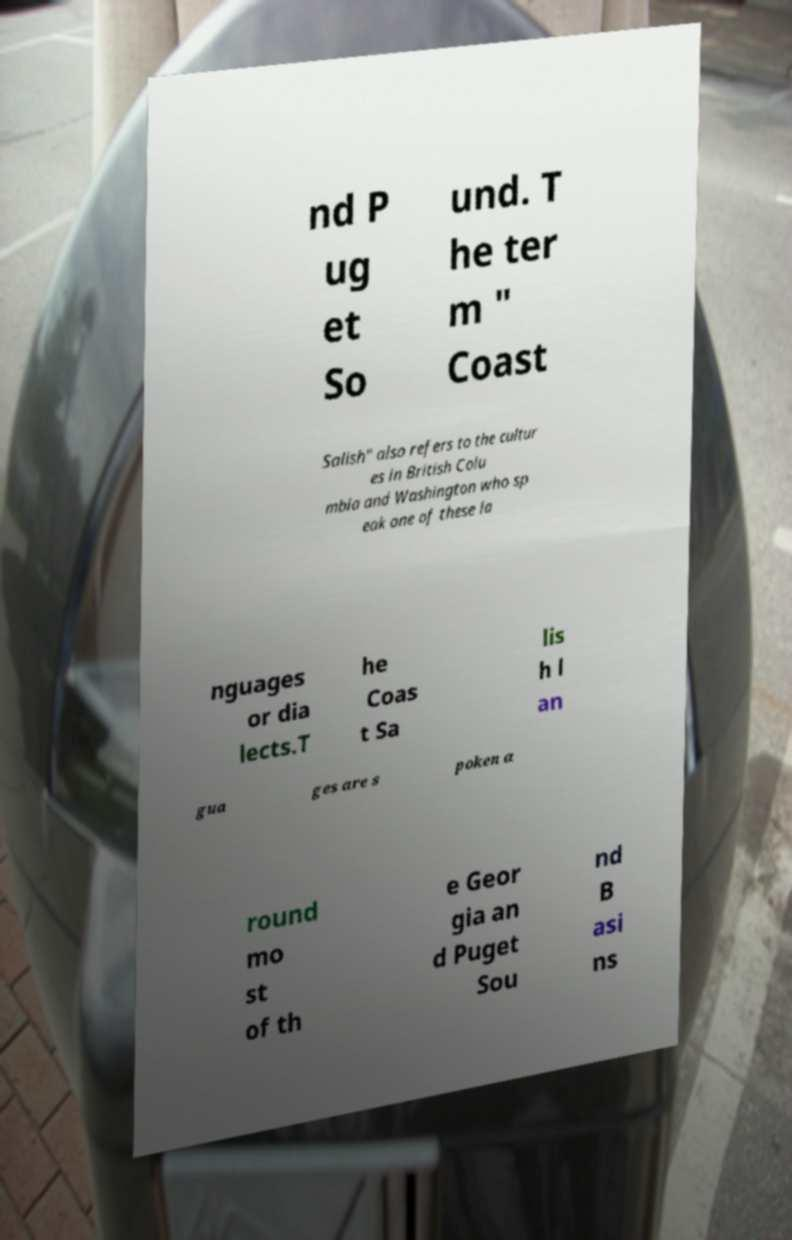I need the written content from this picture converted into text. Can you do that? nd P ug et So und. T he ter m " Coast Salish" also refers to the cultur es in British Colu mbia and Washington who sp eak one of these la nguages or dia lects.T he Coas t Sa lis h l an gua ges are s poken a round mo st of th e Geor gia an d Puget Sou nd B asi ns 